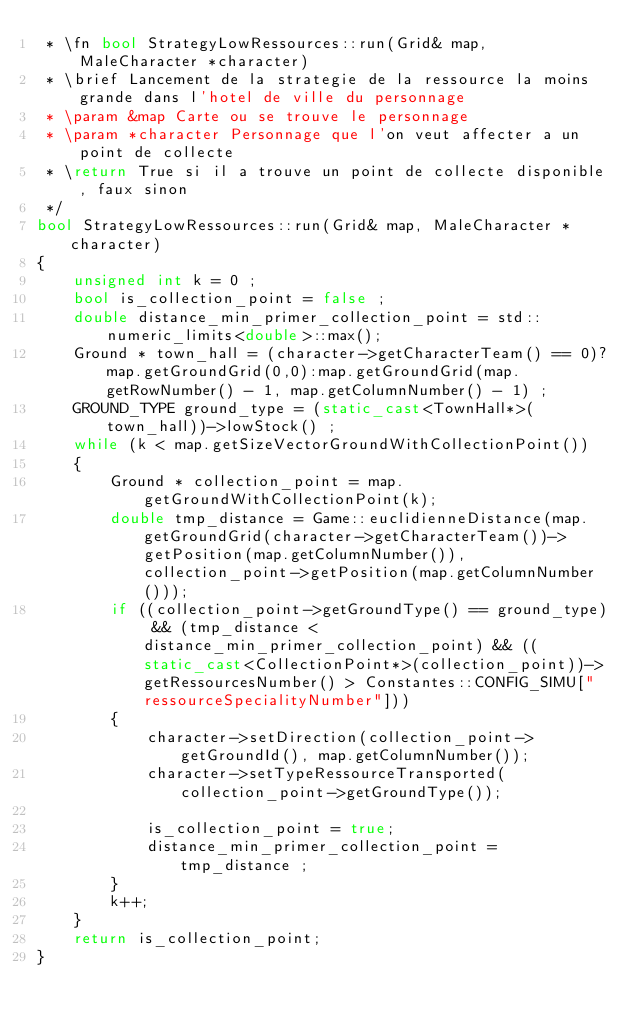<code> <loc_0><loc_0><loc_500><loc_500><_C++_> * \fn bool StrategyLowRessources::run(Grid& map, MaleCharacter *character)
 * \brief Lancement de la strategie de la ressource la moins grande dans l'hotel de ville du personnage
 * \param &map Carte ou se trouve le personnage
 * \param *character Personnage que l'on veut affecter a un point de collecte
 * \return True si il a trouve un point de collecte disponible, faux sinon
 */
bool StrategyLowRessources::run(Grid& map, MaleCharacter *character)
{
    unsigned int k = 0 ;
    bool is_collection_point = false ;
    double distance_min_primer_collection_point = std::numeric_limits<double>::max();
    Ground * town_hall = (character->getCharacterTeam() == 0)?map.getGroundGrid(0,0):map.getGroundGrid(map.getRowNumber() - 1, map.getColumnNumber() - 1) ;
    GROUND_TYPE ground_type = (static_cast<TownHall*>(town_hall))->lowStock() ;
    while (k < map.getSizeVectorGroundWithCollectionPoint())
    {
        Ground * collection_point = map.getGroundWithCollectionPoint(k);
        double tmp_distance = Game::euclidienneDistance(map.getGroundGrid(character->getCharacterTeam())->getPosition(map.getColumnNumber()), collection_point->getPosition(map.getColumnNumber()));
        if ((collection_point->getGroundType() == ground_type) && (tmp_distance < distance_min_primer_collection_point) && ((static_cast<CollectionPoint*>(collection_point))->getRessourcesNumber() > Constantes::CONFIG_SIMU["ressourceSpecialityNumber"]))
        {
            character->setDirection(collection_point->getGroundId(), map.getColumnNumber());
            character->setTypeRessourceTransported(collection_point->getGroundType());

            is_collection_point = true;
            distance_min_primer_collection_point =  tmp_distance ;
        }
        k++;
    }
    return is_collection_point;
}
</code> 